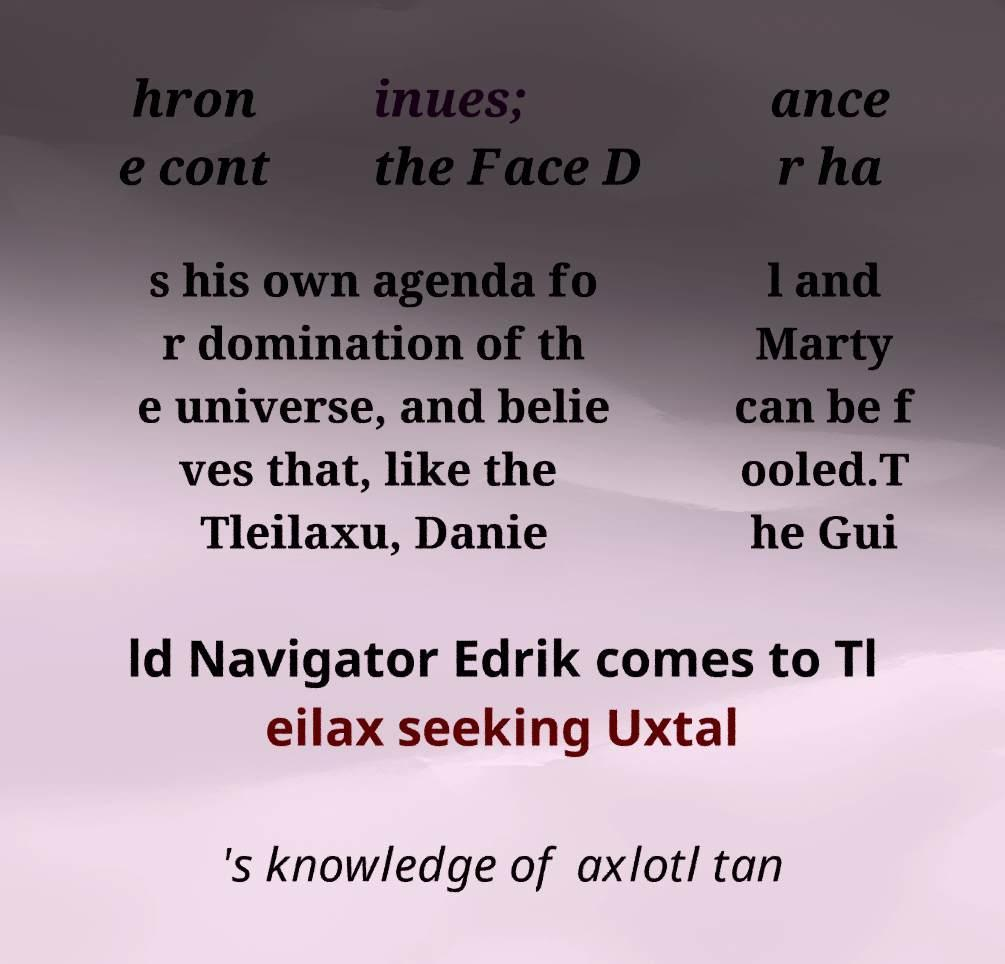What messages or text are displayed in this image? I need them in a readable, typed format. hron e cont inues; the Face D ance r ha s his own agenda fo r domination of th e universe, and belie ves that, like the Tleilaxu, Danie l and Marty can be f ooled.T he Gui ld Navigator Edrik comes to Tl eilax seeking Uxtal 's knowledge of axlotl tan 